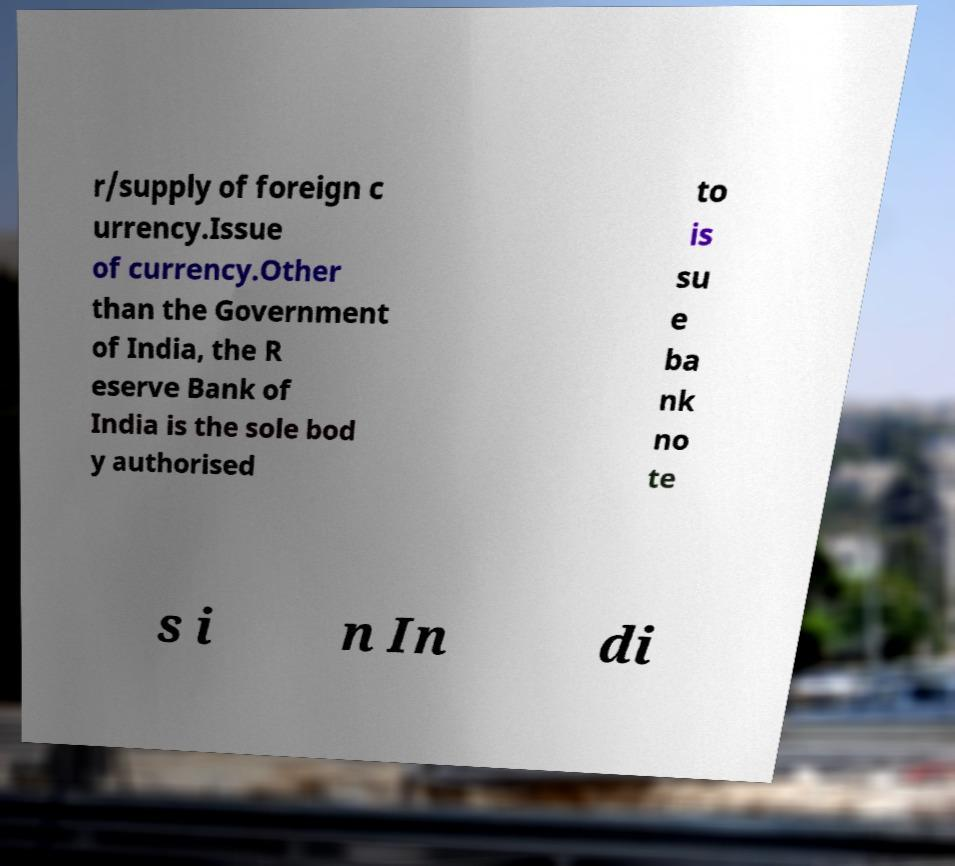Could you extract and type out the text from this image? r/supply of foreign c urrency.Issue of currency.Other than the Government of India, the R eserve Bank of India is the sole bod y authorised to is su e ba nk no te s i n In di 